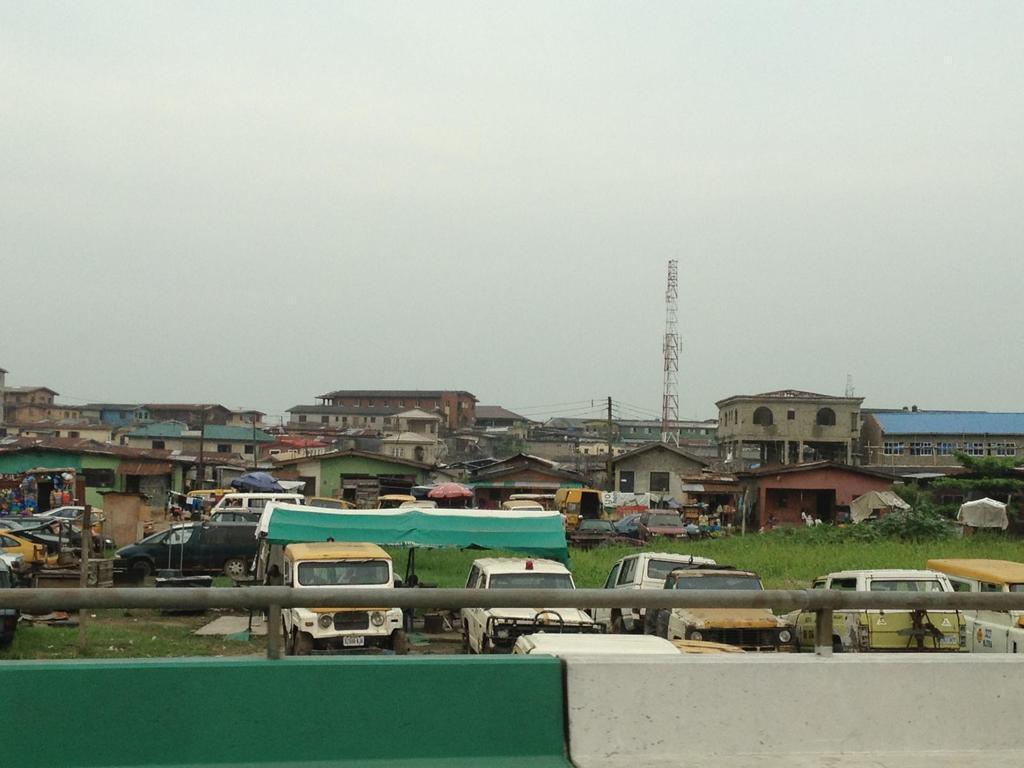Please provide a concise description of this image. In this image, there are a few houses, vehicles, poles with wires. We can also see the ground with some objects. We can see some grass and the sheds. We can also see the sky and a tower. We can also see the wall with an object. 